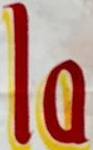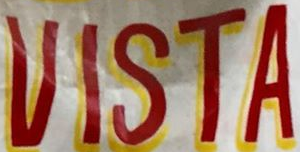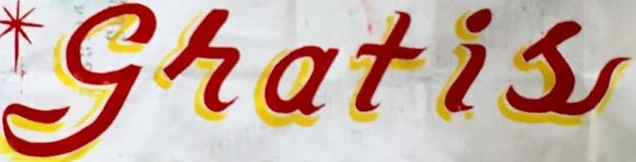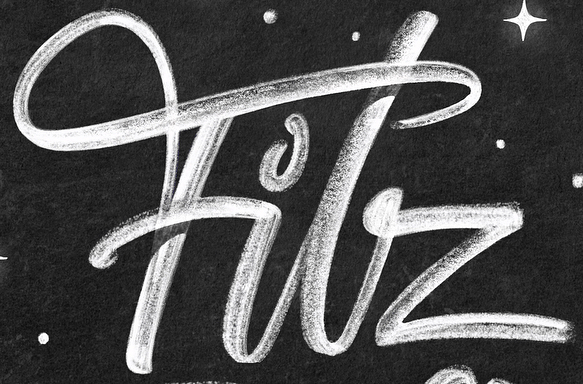Read the text content from these images in order, separated by a semicolon. la; VISTA; gratis; Filz 